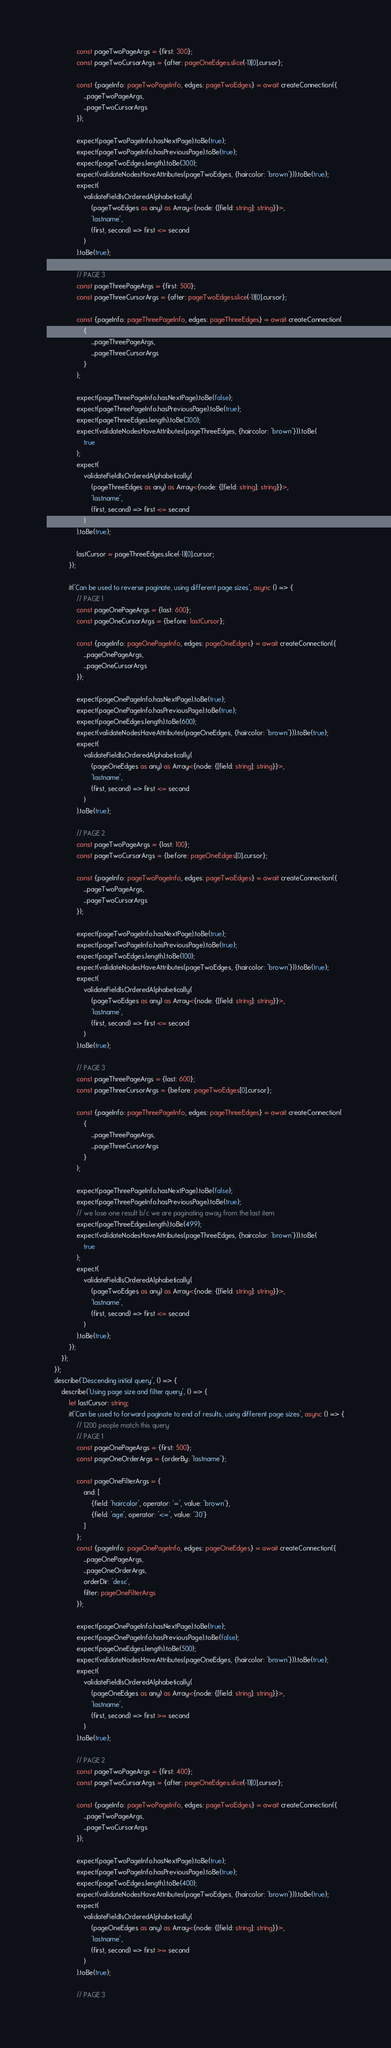Convert code to text. <code><loc_0><loc_0><loc_500><loc_500><_TypeScript_>                const pageTwoPageArgs = {first: 300};
                const pageTwoCursorArgs = {after: pageOneEdges.slice(-1)[0].cursor};

                const {pageInfo: pageTwoPageInfo, edges: pageTwoEdges} = await createConnection({
                    ...pageTwoPageArgs,
                    ...pageTwoCursorArgs
                });

                expect(pageTwoPageInfo.hasNextPage).toBe(true);
                expect(pageTwoPageInfo.hasPreviousPage).toBe(true);
                expect(pageTwoEdges.length).toBe(300);
                expect(validateNodesHaveAttributes(pageTwoEdges, {haircolor: 'brown'})).toBe(true);
                expect(
                    validateFieldIsOrderedAlphabetically(
                        (pageTwoEdges as any) as Array<{node: {[field: string]: string}}>,
                        'lastname',
                        (first, second) => first <= second
                    )
                ).toBe(true);

                // PAGE 3
                const pageThreePageArgs = {first: 500};
                const pageThreeCursorArgs = {after: pageTwoEdges.slice(-1)[0].cursor};

                const {pageInfo: pageThreePageInfo, edges: pageThreeEdges} = await createConnection(
                    {
                        ...pageThreePageArgs,
                        ...pageThreeCursorArgs
                    }
                );

                expect(pageThreePageInfo.hasNextPage).toBe(false);
                expect(pageThreePageInfo.hasPreviousPage).toBe(true);
                expect(pageThreeEdges.length).toBe(300);
                expect(validateNodesHaveAttributes(pageThreeEdges, {haircolor: 'brown'})).toBe(
                    true
                );
                expect(
                    validateFieldIsOrderedAlphabetically(
                        (pageThreeEdges as any) as Array<{node: {[field: string]: string}}>,
                        'lastname',
                        (first, second) => first <= second
                    )
                ).toBe(true);

                lastCursor = pageThreeEdges.slice(-1)[0].cursor;
            });

            it('Can be used to reverse paginate, using different page sizes', async () => {
                // PAGE 1
                const pageOnePageArgs = {last: 600};
                const pageOneCursorArgs = {before: lastCursor};

                const {pageInfo: pageOnePageInfo, edges: pageOneEdges} = await createConnection({
                    ...pageOnePageArgs,
                    ...pageOneCursorArgs
                });

                expect(pageOnePageInfo.hasNextPage).toBe(true);
                expect(pageOnePageInfo.hasPreviousPage).toBe(true);
                expect(pageOneEdges.length).toBe(600);
                expect(validateNodesHaveAttributes(pageOneEdges, {haircolor: 'brown'})).toBe(true);
                expect(
                    validateFieldIsOrderedAlphabetically(
                        (pageOneEdges as any) as Array<{node: {[field: string]: string}}>,
                        'lastname',
                        (first, second) => first <= second
                    )
                ).toBe(true);

                // PAGE 2
                const pageTwoPageArgs = {last: 100};
                const pageTwoCursorArgs = {before: pageOneEdges[0].cursor};

                const {pageInfo: pageTwoPageInfo, edges: pageTwoEdges} = await createConnection({
                    ...pageTwoPageArgs,
                    ...pageTwoCursorArgs
                });

                expect(pageTwoPageInfo.hasNextPage).toBe(true);
                expect(pageTwoPageInfo.hasPreviousPage).toBe(true);
                expect(pageTwoEdges.length).toBe(100);
                expect(validateNodesHaveAttributes(pageTwoEdges, {haircolor: 'brown'})).toBe(true);
                expect(
                    validateFieldIsOrderedAlphabetically(
                        (pageTwoEdges as any) as Array<{node: {[field: string]: string}}>,
                        'lastname',
                        (first, second) => first <= second
                    )
                ).toBe(true);

                // PAGE 3
                const pageThreePageArgs = {last: 600};
                const pageThreeCursorArgs = {before: pageTwoEdges[0].cursor};

                const {pageInfo: pageThreePageInfo, edges: pageThreeEdges} = await createConnection(
                    {
                        ...pageThreePageArgs,
                        ...pageThreeCursorArgs
                    }
                );

                expect(pageThreePageInfo.hasNextPage).toBe(false);
                expect(pageThreePageInfo.hasPreviousPage).toBe(true);
                // we lose one result b/c we are paginating away from the last item
                expect(pageThreeEdges.length).toBe(499);
                expect(validateNodesHaveAttributes(pageThreeEdges, {haircolor: 'brown'})).toBe(
                    true
                );
                expect(
                    validateFieldIsOrderedAlphabetically(
                        (pageTwoEdges as any) as Array<{node: {[field: string]: string}}>,
                        'lastname',
                        (first, second) => first <= second
                    )
                ).toBe(true);
            });
        });
    });
    describe('Descending initial query', () => {
        describe('Using page size and filter query', () => {
            let lastCursor: string;
            it('Can be used to forward paginate to end of results, using different page sizes', async () => {
                // 1200 people match this query
                // PAGE 1
                const pageOnePageArgs = {first: 500};
                const pageOneOrderArgs = {orderBy: 'lastname'};

                const pageOneFilterArgs = {
                    and: [
                        {field: 'haircolor', operator: '=', value: 'brown'},
                        {field: 'age', operator: '<=', value: '30'}
                    ]
                };
                const {pageInfo: pageOnePageInfo, edges: pageOneEdges} = await createConnection({
                    ...pageOnePageArgs,
                    ...pageOneOrderArgs,
                    orderDir: 'desc',
                    filter: pageOneFilterArgs
                });

                expect(pageOnePageInfo.hasNextPage).toBe(true);
                expect(pageOnePageInfo.hasPreviousPage).toBe(false);
                expect(pageOneEdges.length).toBe(500);
                expect(validateNodesHaveAttributes(pageOneEdges, {haircolor: 'brown'})).toBe(true);
                expect(
                    validateFieldIsOrderedAlphabetically(
                        (pageOneEdges as any) as Array<{node: {[field: string]: string}}>,
                        'lastname',
                        (first, second) => first >= second
                    )
                ).toBe(true);

                // PAGE 2
                const pageTwoPageArgs = {first: 400};
                const pageTwoCursorArgs = {after: pageOneEdges.slice(-1)[0].cursor};

                const {pageInfo: pageTwoPageInfo, edges: pageTwoEdges} = await createConnection({
                    ...pageTwoPageArgs,
                    ...pageTwoCursorArgs
                });

                expect(pageTwoPageInfo.hasNextPage).toBe(true);
                expect(pageTwoPageInfo.hasPreviousPage).toBe(true);
                expect(pageTwoEdges.length).toBe(400);
                expect(validateNodesHaveAttributes(pageTwoEdges, {haircolor: 'brown'})).toBe(true);
                expect(
                    validateFieldIsOrderedAlphabetically(
                        (pageOneEdges as any) as Array<{node: {[field: string]: string}}>,
                        'lastname',
                        (first, second) => first >= second
                    )
                ).toBe(true);

                // PAGE 3</code> 